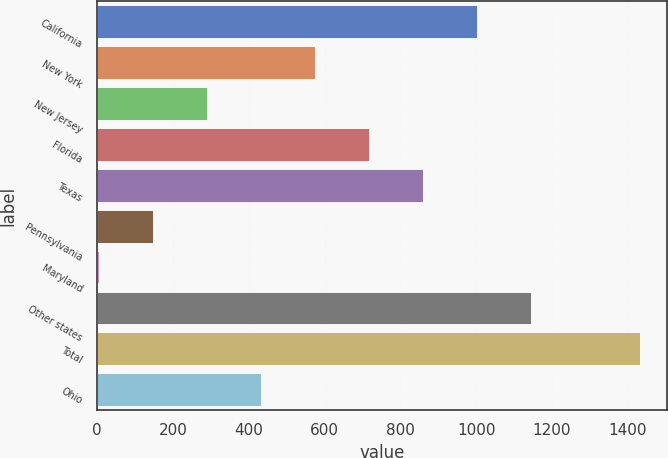Convert chart. <chart><loc_0><loc_0><loc_500><loc_500><bar_chart><fcel>California<fcel>New York<fcel>New Jersey<fcel>Florida<fcel>Texas<fcel>Pennsylvania<fcel>Maryland<fcel>Other states<fcel>Total<fcel>Ohio<nl><fcel>1002.9<fcel>574.8<fcel>289.4<fcel>717.5<fcel>860.2<fcel>146.7<fcel>4<fcel>1145.6<fcel>1431<fcel>432.1<nl></chart> 